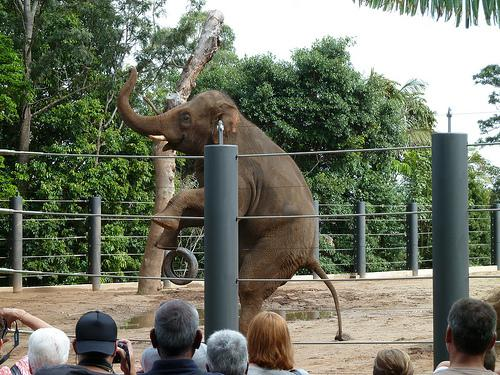Question: how many elephants are in the photo?
Choices:
A. Two.
B. Four.
C. Five.
D. One.
Answer with the letter. Answer: D Question: what color is the elephant?
Choices:
A. White.
B. Blue.
C. Pink.
D. Grey.
Answer with the letter. Answer: D Question: what are the green objects in the background?
Choices:
A. Shrubs.
B. Walls.
C. Buildings.
D. Trees.
Answer with the letter. Answer: D Question: how many tusks are visible?
Choices:
A. Two.
B. Zero.
C. One.
D. Three.
Answer with the letter. Answer: C 